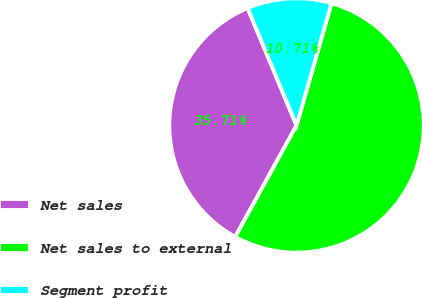Convert chart. <chart><loc_0><loc_0><loc_500><loc_500><pie_chart><fcel>Net sales<fcel>Net sales to external<fcel>Segment profit<nl><fcel>35.71%<fcel>53.57%<fcel>10.71%<nl></chart> 